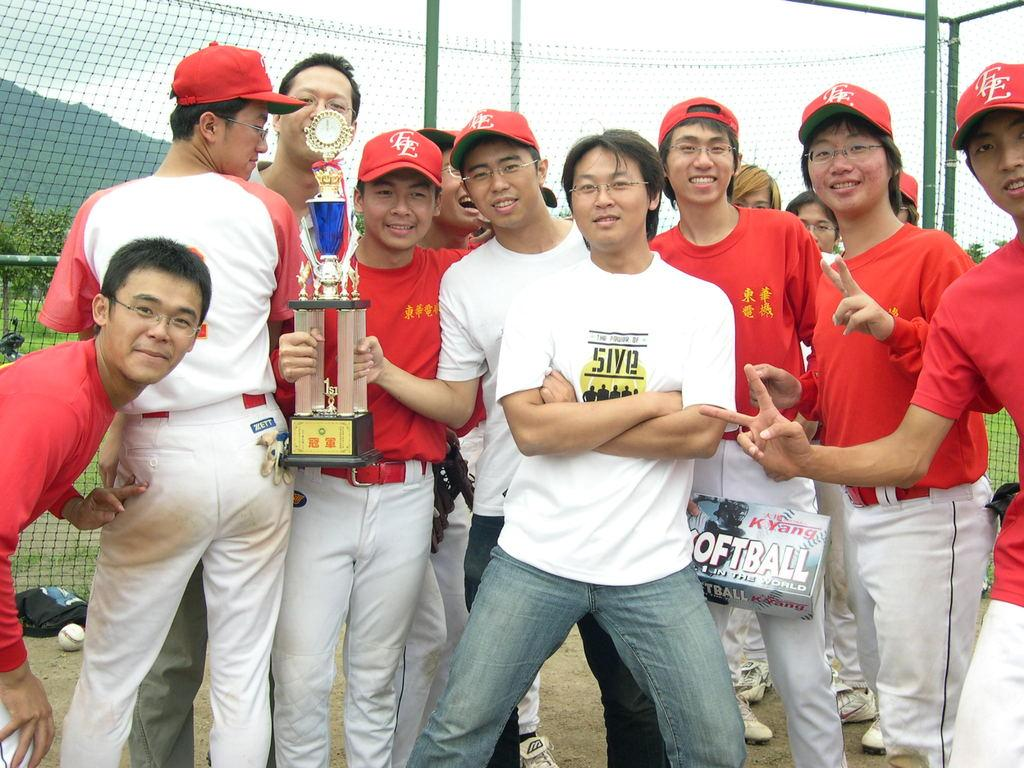<image>
Render a clear and concise summary of the photo. The baseball players hats have the letters E and E on them 